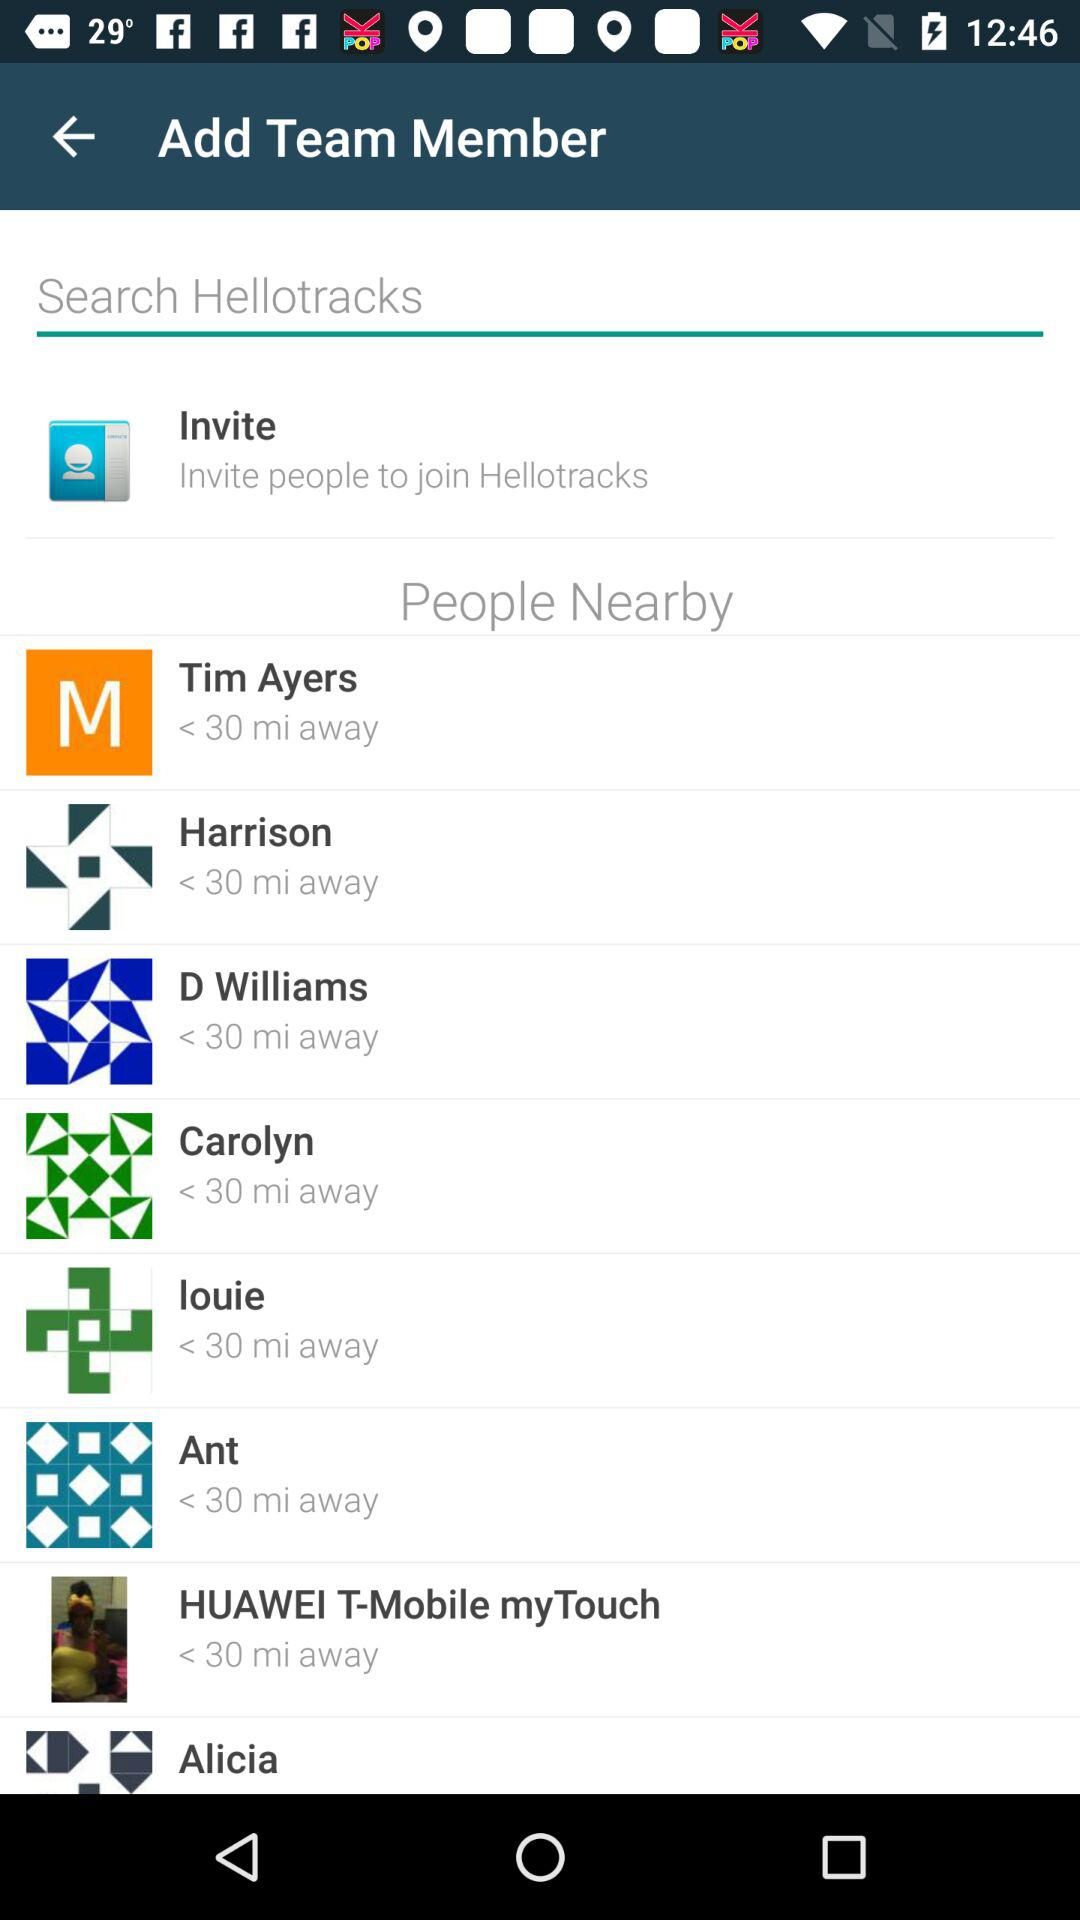How far is the Ant? Ant is less than 30 miles away. 